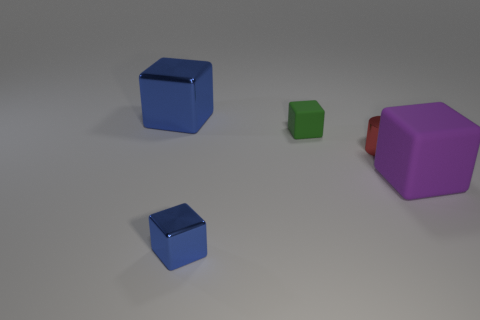Subtract all big blue cubes. How many cubes are left? 3 Subtract all gray cylinders. How many blue blocks are left? 2 Add 2 small gray metal cubes. How many objects exist? 7 Subtract all purple cubes. How many cubes are left? 3 Subtract all cubes. How many objects are left? 1 Add 5 tiny gray shiny spheres. How many tiny gray shiny spheres exist? 5 Subtract 0 green cylinders. How many objects are left? 5 Subtract all green cubes. Subtract all purple cylinders. How many cubes are left? 3 Subtract all small red objects. Subtract all large blue cubes. How many objects are left? 3 Add 5 tiny red cylinders. How many tiny red cylinders are left? 6 